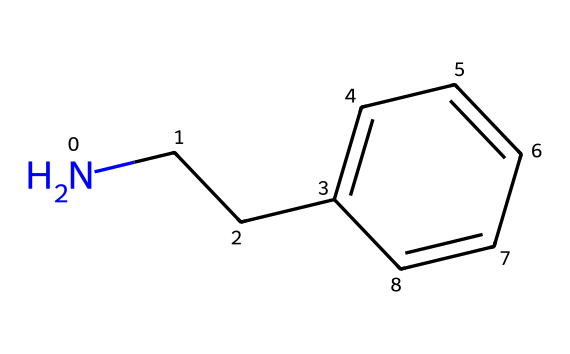What is the molecular formula of phenylethylamine? By analyzing the SMILES representation, "NCCc1ccccc1", we can identify the atoms present: there are 8 carbon (C) atoms, 11 hydrogen (H) atoms, and 1 nitrogen (N) atom. This leads us to the molecular formula C8H11N.
Answer: C8H11N How many carbon atoms are in phenylethylamine? In the SMILES structure, we count the "C" characters, which indicate carbon atoms. There are 8 carbon atoms in total.
Answer: 8 What type of functional group does phenylethylamine contain? The "N" in the SMILES represents a nitrogen atom bonded to carbon, indicating the presence of an amine functional group. The amine group is identified by the nitrogen atom attached to aliphatic carbon chains.
Answer: amine Which part of the molecule is responsible for mood enhancement? The structure contains a phenyl group (the aromatic ring) and an amine group (the nitrogen bond), which are linked; this combination is associated with mood-enhancing effects when present in the brain.
Answer: phenylamine group What is the total number of bonds between the nitrogen and carbon atoms in phenylethylamine? In the structure, the nitrogen (N) atom is connected to two carbon (C) atoms, resulting in a total of two single bonds between them.
Answer: 2 Is phenylethylamine a food additive found in chocolate? The molecular structure provided correlates to phenylethylamine, which is recognized as a compound found in chocolate and is often classified as a food additive.
Answer: yes How does the presence of the nitrogen atom affect phenylethylamine's properties? The nitrogen atom introduces basicity and potential for forming hydrogen bonds, which influences the solubility and reactivity of phenylethylamine compared to hydrocarbons without nitrogen.
Answer: increases reactivity 